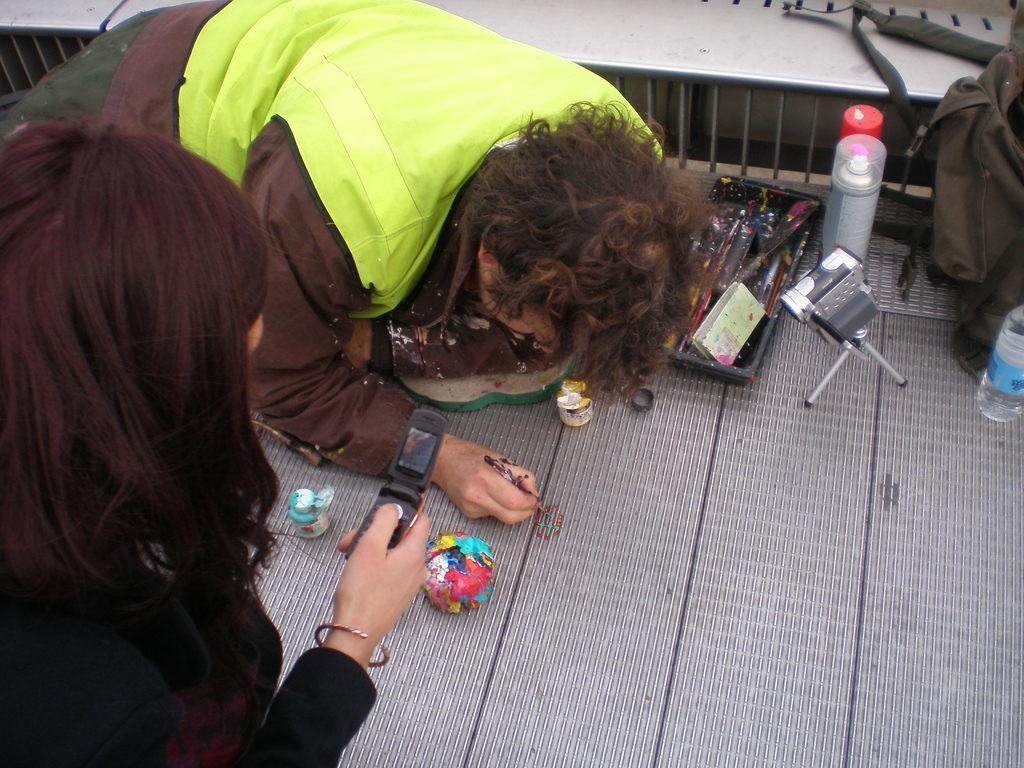In one or two sentences, can you explain what this image depicts? In this image we can see two people. One person is holding mobile the hand and wearing black color dress. The other person is on the floor and painting on the floor. We can see colors, brushes, camera, bag, bottles and container on the floor. 